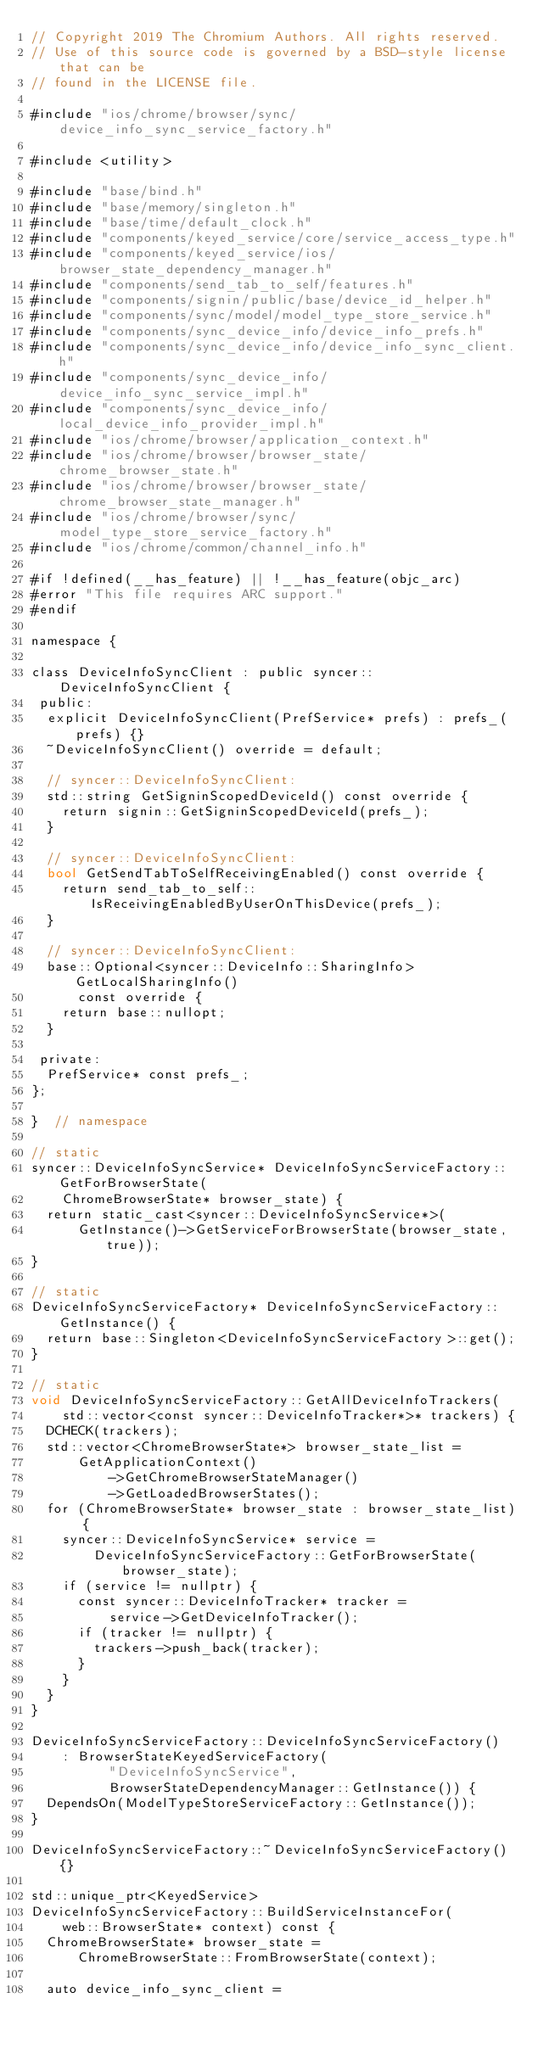Convert code to text. <code><loc_0><loc_0><loc_500><loc_500><_ObjectiveC_>// Copyright 2019 The Chromium Authors. All rights reserved.
// Use of this source code is governed by a BSD-style license that can be
// found in the LICENSE file.

#include "ios/chrome/browser/sync/device_info_sync_service_factory.h"

#include <utility>

#include "base/bind.h"
#include "base/memory/singleton.h"
#include "base/time/default_clock.h"
#include "components/keyed_service/core/service_access_type.h"
#include "components/keyed_service/ios/browser_state_dependency_manager.h"
#include "components/send_tab_to_self/features.h"
#include "components/signin/public/base/device_id_helper.h"
#include "components/sync/model/model_type_store_service.h"
#include "components/sync_device_info/device_info_prefs.h"
#include "components/sync_device_info/device_info_sync_client.h"
#include "components/sync_device_info/device_info_sync_service_impl.h"
#include "components/sync_device_info/local_device_info_provider_impl.h"
#include "ios/chrome/browser/application_context.h"
#include "ios/chrome/browser/browser_state/chrome_browser_state.h"
#include "ios/chrome/browser/browser_state/chrome_browser_state_manager.h"
#include "ios/chrome/browser/sync/model_type_store_service_factory.h"
#include "ios/chrome/common/channel_info.h"

#if !defined(__has_feature) || !__has_feature(objc_arc)
#error "This file requires ARC support."
#endif

namespace {

class DeviceInfoSyncClient : public syncer::DeviceInfoSyncClient {
 public:
  explicit DeviceInfoSyncClient(PrefService* prefs) : prefs_(prefs) {}
  ~DeviceInfoSyncClient() override = default;

  // syncer::DeviceInfoSyncClient:
  std::string GetSigninScopedDeviceId() const override {
    return signin::GetSigninScopedDeviceId(prefs_);
  }

  // syncer::DeviceInfoSyncClient:
  bool GetSendTabToSelfReceivingEnabled() const override {
    return send_tab_to_self::IsReceivingEnabledByUserOnThisDevice(prefs_);
  }

  // syncer::DeviceInfoSyncClient:
  base::Optional<syncer::DeviceInfo::SharingInfo> GetLocalSharingInfo()
      const override {
    return base::nullopt;
  }

 private:
  PrefService* const prefs_;
};

}  // namespace

// static
syncer::DeviceInfoSyncService* DeviceInfoSyncServiceFactory::GetForBrowserState(
    ChromeBrowserState* browser_state) {
  return static_cast<syncer::DeviceInfoSyncService*>(
      GetInstance()->GetServiceForBrowserState(browser_state, true));
}

// static
DeviceInfoSyncServiceFactory* DeviceInfoSyncServiceFactory::GetInstance() {
  return base::Singleton<DeviceInfoSyncServiceFactory>::get();
}

// static
void DeviceInfoSyncServiceFactory::GetAllDeviceInfoTrackers(
    std::vector<const syncer::DeviceInfoTracker*>* trackers) {
  DCHECK(trackers);
  std::vector<ChromeBrowserState*> browser_state_list =
      GetApplicationContext()
          ->GetChromeBrowserStateManager()
          ->GetLoadedBrowserStates();
  for (ChromeBrowserState* browser_state : browser_state_list) {
    syncer::DeviceInfoSyncService* service =
        DeviceInfoSyncServiceFactory::GetForBrowserState(browser_state);
    if (service != nullptr) {
      const syncer::DeviceInfoTracker* tracker =
          service->GetDeviceInfoTracker();
      if (tracker != nullptr) {
        trackers->push_back(tracker);
      }
    }
  }
}

DeviceInfoSyncServiceFactory::DeviceInfoSyncServiceFactory()
    : BrowserStateKeyedServiceFactory(
          "DeviceInfoSyncService",
          BrowserStateDependencyManager::GetInstance()) {
  DependsOn(ModelTypeStoreServiceFactory::GetInstance());
}

DeviceInfoSyncServiceFactory::~DeviceInfoSyncServiceFactory() {}

std::unique_ptr<KeyedService>
DeviceInfoSyncServiceFactory::BuildServiceInstanceFor(
    web::BrowserState* context) const {
  ChromeBrowserState* browser_state =
      ChromeBrowserState::FromBrowserState(context);

  auto device_info_sync_client =</code> 